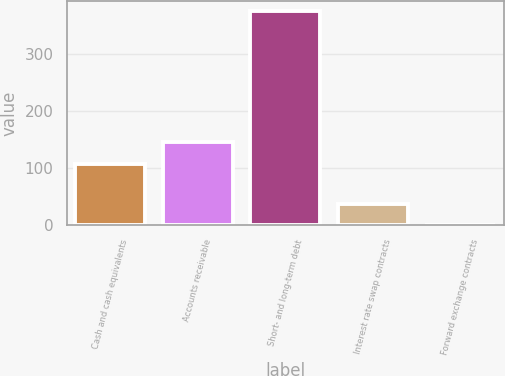Convert chart. <chart><loc_0><loc_0><loc_500><loc_500><bar_chart><fcel>Cash and cash equivalents<fcel>Accounts receivable<fcel>Short- and long-term debt<fcel>Interest rate swap contracts<fcel>Forward exchange contracts<nl><fcel>108.4<fcel>145.88<fcel>375.1<fcel>37.78<fcel>0.3<nl></chart> 